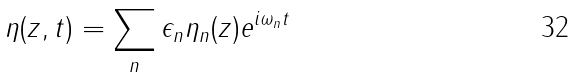Convert formula to latex. <formula><loc_0><loc_0><loc_500><loc_500>\eta ( z , t ) = \sum _ { n } \epsilon _ { n } \eta _ { n } ( z ) e ^ { i \omega _ { n } t }</formula> 